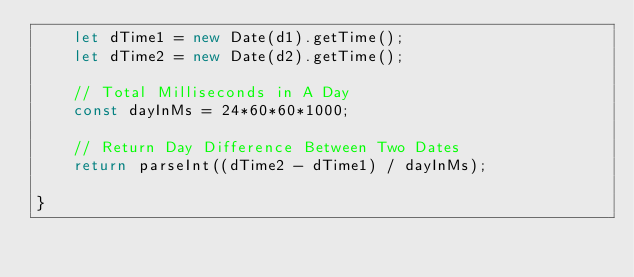<code> <loc_0><loc_0><loc_500><loc_500><_JavaScript_>    let dTime1 = new Date(d1).getTime();
    let dTime2 = new Date(d2).getTime();

    // Total Milliseconds in A Day
    const dayInMs = 24*60*60*1000;

    // Return Day Difference Between Two Dates
    return parseInt((dTime2 - dTime1) / dayInMs);

}</code> 